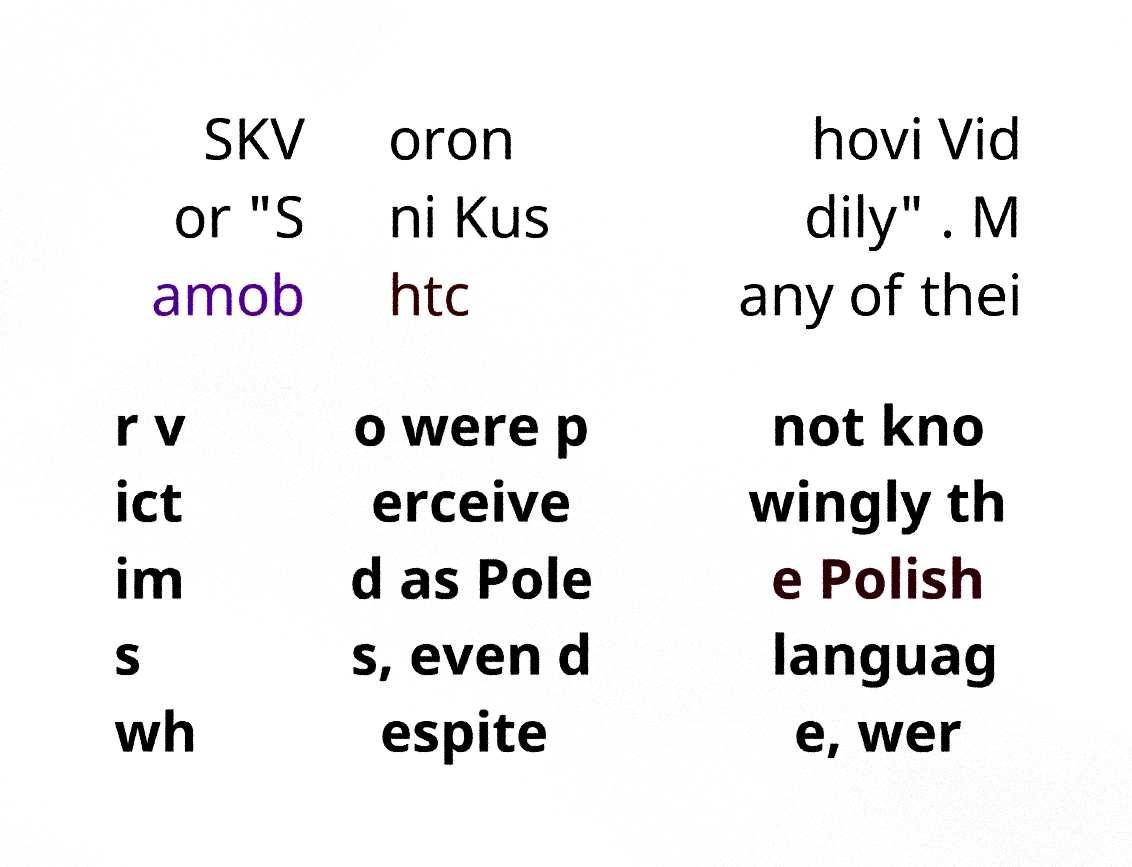Can you accurately transcribe the text from the provided image for me? SKV or "S amob oron ni Kus htc hovi Vid dily" . M any of thei r v ict im s wh o were p erceive d as Pole s, even d espite not kno wingly th e Polish languag e, wer 